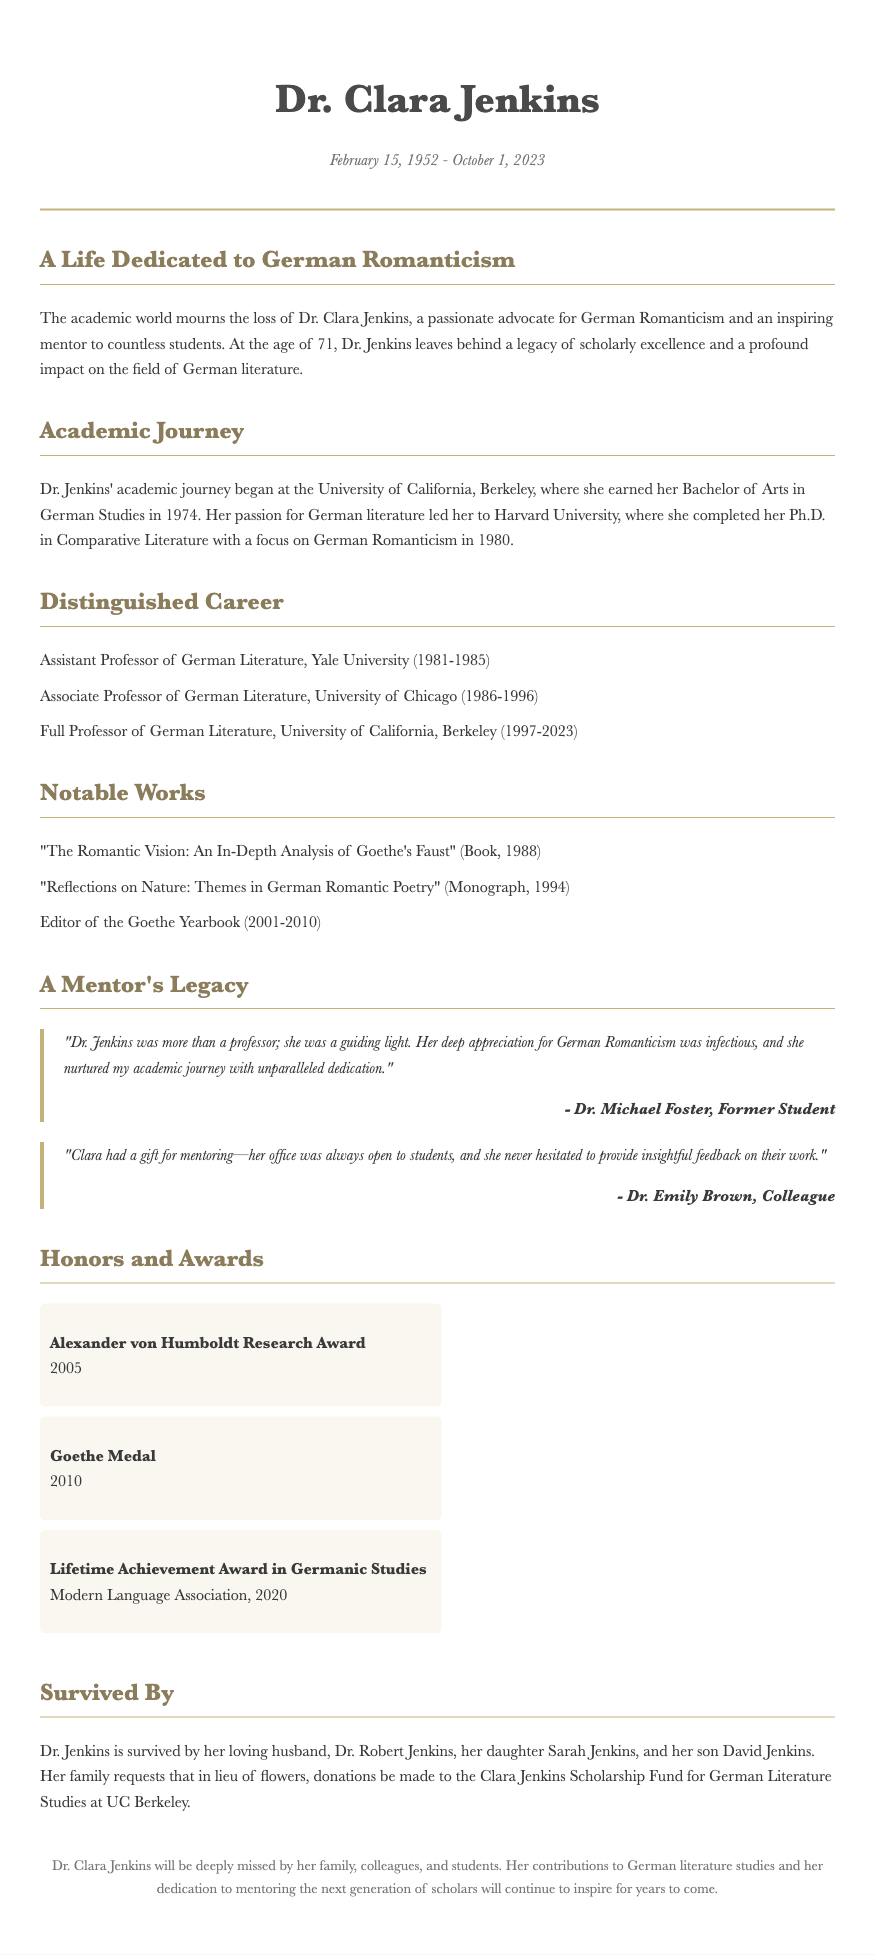What is Dr. Clara Jenkins' date of birth? The document states Dr. Clara Jenkins was born on February 15, 1952.
Answer: February 15, 1952 What was Dr. Jenkins' highest academic degree? The document mentions she completed her Ph.D. in Comparative Literature.
Answer: Ph.D Which university did Dr. Jenkins teach at from 1997 to 2023? The document lists the University of California, Berkeley as her final teaching position.
Answer: University of California, Berkeley What is the title of one notable work by Dr. Jenkins? The document provides several titles, one being "The Romantic Vision: An In-Depth Analysis of Goethe's Faust".
Answer: "The Romantic Vision: An In-Depth Analysis of Goethe's Faust" What award did Dr. Jenkins receive in 2010? The document states she received the Goethe Medal in that year.
Answer: Goethe Medal How many children did Dr. Jenkins have? The document indicates she had two children: Sarah and David.
Answer: Two What was the focus of Dr. Jenkins' Ph.D. studies? The document specifies that her focus was on German Romanticism.
Answer: German Romanticism Who described Dr. Jenkins as a "guiding light"? The document attributes this description to Dr. Michael Foster, a former student.
Answer: Dr. Michael Foster 